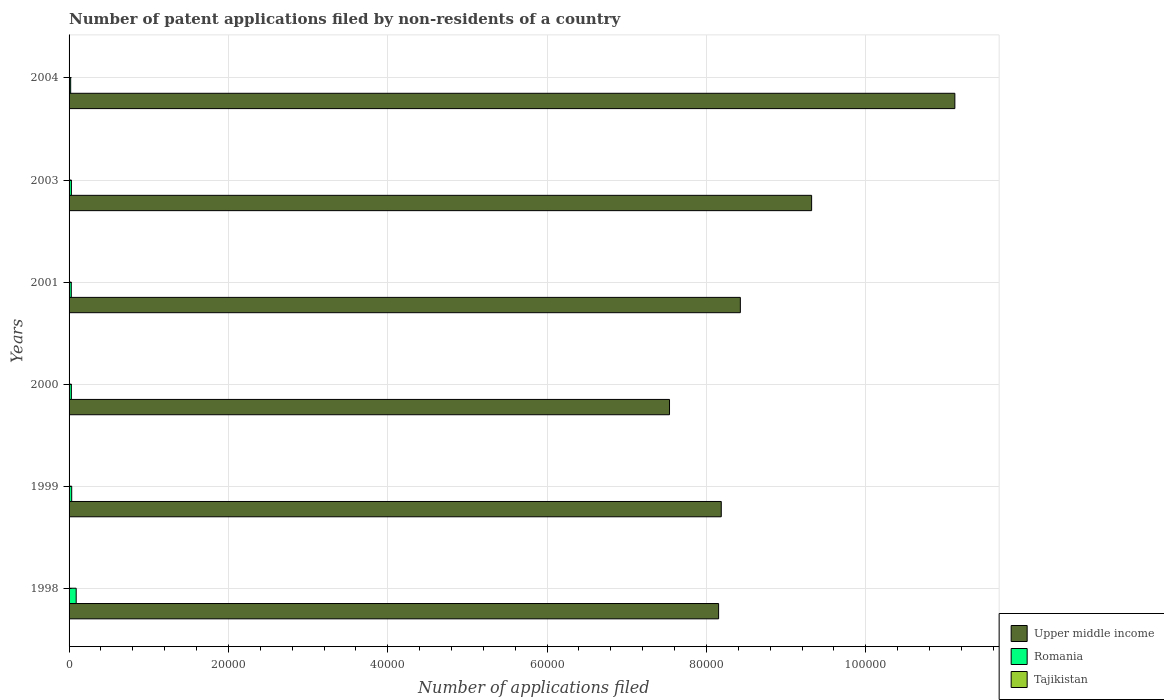How many different coloured bars are there?
Provide a succinct answer. 3. How many groups of bars are there?
Your answer should be very brief. 6. How many bars are there on the 3rd tick from the top?
Keep it short and to the point. 3. How many bars are there on the 2nd tick from the bottom?
Your answer should be compact. 3. What is the number of applications filed in Romania in 2004?
Ensure brevity in your answer.  200. Across all years, what is the minimum number of applications filed in Upper middle income?
Your response must be concise. 7.54e+04. In which year was the number of applications filed in Upper middle income maximum?
Your answer should be very brief. 2004. In which year was the number of applications filed in Upper middle income minimum?
Your answer should be compact. 2000. What is the total number of applications filed in Tajikistan in the graph?
Offer a very short reply. 25. What is the difference between the number of applications filed in Upper middle income in 1999 and the number of applications filed in Tajikistan in 2003?
Make the answer very short. 8.19e+04. What is the average number of applications filed in Romania per year?
Offer a terse response. 380.17. In the year 2003, what is the difference between the number of applications filed in Tajikistan and number of applications filed in Upper middle income?
Provide a short and direct response. -9.32e+04. In how many years, is the number of applications filed in Tajikistan greater than 44000 ?
Provide a short and direct response. 0. What is the ratio of the number of applications filed in Upper middle income in 2003 to that in 2004?
Keep it short and to the point. 0.84. Is the difference between the number of applications filed in Tajikistan in 1998 and 2003 greater than the difference between the number of applications filed in Upper middle income in 1998 and 2003?
Provide a short and direct response. Yes. What is the difference between the highest and the second highest number of applications filed in Tajikistan?
Give a very brief answer. 2. What is the difference between the highest and the lowest number of applications filed in Upper middle income?
Make the answer very short. 3.58e+04. In how many years, is the number of applications filed in Tajikistan greater than the average number of applications filed in Tajikistan taken over all years?
Ensure brevity in your answer.  3. Is the sum of the number of applications filed in Upper middle income in 1998 and 2001 greater than the maximum number of applications filed in Romania across all years?
Your response must be concise. Yes. What does the 1st bar from the top in 2004 represents?
Make the answer very short. Tajikistan. What does the 2nd bar from the bottom in 2004 represents?
Give a very brief answer. Romania. How many years are there in the graph?
Your answer should be very brief. 6. What is the difference between two consecutive major ticks on the X-axis?
Keep it short and to the point. 2.00e+04. What is the title of the graph?
Ensure brevity in your answer.  Number of patent applications filed by non-residents of a country. Does "Bolivia" appear as one of the legend labels in the graph?
Your answer should be compact. No. What is the label or title of the X-axis?
Your response must be concise. Number of applications filed. What is the Number of applications filed of Upper middle income in 1998?
Offer a very short reply. 8.15e+04. What is the Number of applications filed of Romania in 1998?
Your response must be concise. 894. What is the Number of applications filed of Tajikistan in 1998?
Ensure brevity in your answer.  9. What is the Number of applications filed in Upper middle income in 1999?
Offer a very short reply. 8.19e+04. What is the Number of applications filed of Romania in 1999?
Keep it short and to the point. 330. What is the Number of applications filed in Tajikistan in 1999?
Keep it short and to the point. 5. What is the Number of applications filed in Upper middle income in 2000?
Your response must be concise. 7.54e+04. What is the Number of applications filed of Romania in 2000?
Provide a succinct answer. 287. What is the Number of applications filed in Tajikistan in 2000?
Keep it short and to the point. 7. What is the Number of applications filed of Upper middle income in 2001?
Give a very brief answer. 8.43e+04. What is the Number of applications filed in Romania in 2001?
Offer a very short reply. 277. What is the Number of applications filed of Tajikistan in 2001?
Provide a succinct answer. 1. What is the Number of applications filed of Upper middle income in 2003?
Offer a very short reply. 9.32e+04. What is the Number of applications filed in Romania in 2003?
Keep it short and to the point. 293. What is the Number of applications filed of Tajikistan in 2003?
Your response must be concise. 1. What is the Number of applications filed of Upper middle income in 2004?
Give a very brief answer. 1.11e+05. What is the Number of applications filed in Tajikistan in 2004?
Keep it short and to the point. 2. Across all years, what is the maximum Number of applications filed in Upper middle income?
Your answer should be very brief. 1.11e+05. Across all years, what is the maximum Number of applications filed in Romania?
Your answer should be compact. 894. Across all years, what is the maximum Number of applications filed in Tajikistan?
Your response must be concise. 9. Across all years, what is the minimum Number of applications filed in Upper middle income?
Keep it short and to the point. 7.54e+04. Across all years, what is the minimum Number of applications filed in Romania?
Give a very brief answer. 200. Across all years, what is the minimum Number of applications filed in Tajikistan?
Offer a terse response. 1. What is the total Number of applications filed in Upper middle income in the graph?
Offer a very short reply. 5.27e+05. What is the total Number of applications filed of Romania in the graph?
Keep it short and to the point. 2281. What is the total Number of applications filed of Tajikistan in the graph?
Offer a very short reply. 25. What is the difference between the Number of applications filed of Upper middle income in 1998 and that in 1999?
Give a very brief answer. -333. What is the difference between the Number of applications filed of Romania in 1998 and that in 1999?
Provide a short and direct response. 564. What is the difference between the Number of applications filed in Upper middle income in 1998 and that in 2000?
Offer a terse response. 6162. What is the difference between the Number of applications filed in Romania in 1998 and that in 2000?
Your answer should be very brief. 607. What is the difference between the Number of applications filed of Upper middle income in 1998 and that in 2001?
Offer a terse response. -2727. What is the difference between the Number of applications filed of Romania in 1998 and that in 2001?
Provide a short and direct response. 617. What is the difference between the Number of applications filed in Upper middle income in 1998 and that in 2003?
Your answer should be very brief. -1.17e+04. What is the difference between the Number of applications filed of Romania in 1998 and that in 2003?
Ensure brevity in your answer.  601. What is the difference between the Number of applications filed in Upper middle income in 1998 and that in 2004?
Ensure brevity in your answer.  -2.97e+04. What is the difference between the Number of applications filed in Romania in 1998 and that in 2004?
Ensure brevity in your answer.  694. What is the difference between the Number of applications filed of Tajikistan in 1998 and that in 2004?
Your answer should be compact. 7. What is the difference between the Number of applications filed of Upper middle income in 1999 and that in 2000?
Offer a terse response. 6495. What is the difference between the Number of applications filed in Romania in 1999 and that in 2000?
Your answer should be very brief. 43. What is the difference between the Number of applications filed in Tajikistan in 1999 and that in 2000?
Offer a terse response. -2. What is the difference between the Number of applications filed of Upper middle income in 1999 and that in 2001?
Make the answer very short. -2394. What is the difference between the Number of applications filed of Tajikistan in 1999 and that in 2001?
Make the answer very short. 4. What is the difference between the Number of applications filed in Upper middle income in 1999 and that in 2003?
Provide a succinct answer. -1.13e+04. What is the difference between the Number of applications filed in Romania in 1999 and that in 2003?
Provide a short and direct response. 37. What is the difference between the Number of applications filed in Tajikistan in 1999 and that in 2003?
Ensure brevity in your answer.  4. What is the difference between the Number of applications filed of Upper middle income in 1999 and that in 2004?
Keep it short and to the point. -2.93e+04. What is the difference between the Number of applications filed in Romania in 1999 and that in 2004?
Keep it short and to the point. 130. What is the difference between the Number of applications filed in Tajikistan in 1999 and that in 2004?
Your answer should be compact. 3. What is the difference between the Number of applications filed of Upper middle income in 2000 and that in 2001?
Offer a very short reply. -8889. What is the difference between the Number of applications filed in Romania in 2000 and that in 2001?
Offer a terse response. 10. What is the difference between the Number of applications filed of Upper middle income in 2000 and that in 2003?
Ensure brevity in your answer.  -1.78e+04. What is the difference between the Number of applications filed of Tajikistan in 2000 and that in 2003?
Your response must be concise. 6. What is the difference between the Number of applications filed in Upper middle income in 2000 and that in 2004?
Offer a very short reply. -3.58e+04. What is the difference between the Number of applications filed of Romania in 2000 and that in 2004?
Keep it short and to the point. 87. What is the difference between the Number of applications filed of Tajikistan in 2000 and that in 2004?
Give a very brief answer. 5. What is the difference between the Number of applications filed in Upper middle income in 2001 and that in 2003?
Provide a short and direct response. -8949. What is the difference between the Number of applications filed in Tajikistan in 2001 and that in 2003?
Offer a very short reply. 0. What is the difference between the Number of applications filed of Upper middle income in 2001 and that in 2004?
Ensure brevity in your answer.  -2.69e+04. What is the difference between the Number of applications filed of Upper middle income in 2003 and that in 2004?
Your answer should be compact. -1.80e+04. What is the difference between the Number of applications filed of Romania in 2003 and that in 2004?
Your answer should be very brief. 93. What is the difference between the Number of applications filed of Tajikistan in 2003 and that in 2004?
Give a very brief answer. -1. What is the difference between the Number of applications filed in Upper middle income in 1998 and the Number of applications filed in Romania in 1999?
Your response must be concise. 8.12e+04. What is the difference between the Number of applications filed in Upper middle income in 1998 and the Number of applications filed in Tajikistan in 1999?
Your answer should be compact. 8.15e+04. What is the difference between the Number of applications filed in Romania in 1998 and the Number of applications filed in Tajikistan in 1999?
Your answer should be compact. 889. What is the difference between the Number of applications filed in Upper middle income in 1998 and the Number of applications filed in Romania in 2000?
Give a very brief answer. 8.12e+04. What is the difference between the Number of applications filed in Upper middle income in 1998 and the Number of applications filed in Tajikistan in 2000?
Your response must be concise. 8.15e+04. What is the difference between the Number of applications filed of Romania in 1998 and the Number of applications filed of Tajikistan in 2000?
Your answer should be compact. 887. What is the difference between the Number of applications filed in Upper middle income in 1998 and the Number of applications filed in Romania in 2001?
Keep it short and to the point. 8.13e+04. What is the difference between the Number of applications filed in Upper middle income in 1998 and the Number of applications filed in Tajikistan in 2001?
Make the answer very short. 8.15e+04. What is the difference between the Number of applications filed of Romania in 1998 and the Number of applications filed of Tajikistan in 2001?
Offer a terse response. 893. What is the difference between the Number of applications filed in Upper middle income in 1998 and the Number of applications filed in Romania in 2003?
Give a very brief answer. 8.12e+04. What is the difference between the Number of applications filed in Upper middle income in 1998 and the Number of applications filed in Tajikistan in 2003?
Provide a short and direct response. 8.15e+04. What is the difference between the Number of applications filed of Romania in 1998 and the Number of applications filed of Tajikistan in 2003?
Make the answer very short. 893. What is the difference between the Number of applications filed of Upper middle income in 1998 and the Number of applications filed of Romania in 2004?
Your answer should be compact. 8.13e+04. What is the difference between the Number of applications filed in Upper middle income in 1998 and the Number of applications filed in Tajikistan in 2004?
Ensure brevity in your answer.  8.15e+04. What is the difference between the Number of applications filed of Romania in 1998 and the Number of applications filed of Tajikistan in 2004?
Provide a succinct answer. 892. What is the difference between the Number of applications filed of Upper middle income in 1999 and the Number of applications filed of Romania in 2000?
Make the answer very short. 8.16e+04. What is the difference between the Number of applications filed in Upper middle income in 1999 and the Number of applications filed in Tajikistan in 2000?
Keep it short and to the point. 8.19e+04. What is the difference between the Number of applications filed in Romania in 1999 and the Number of applications filed in Tajikistan in 2000?
Your response must be concise. 323. What is the difference between the Number of applications filed of Upper middle income in 1999 and the Number of applications filed of Romania in 2001?
Provide a succinct answer. 8.16e+04. What is the difference between the Number of applications filed in Upper middle income in 1999 and the Number of applications filed in Tajikistan in 2001?
Offer a very short reply. 8.19e+04. What is the difference between the Number of applications filed of Romania in 1999 and the Number of applications filed of Tajikistan in 2001?
Your answer should be very brief. 329. What is the difference between the Number of applications filed in Upper middle income in 1999 and the Number of applications filed in Romania in 2003?
Ensure brevity in your answer.  8.16e+04. What is the difference between the Number of applications filed of Upper middle income in 1999 and the Number of applications filed of Tajikistan in 2003?
Your response must be concise. 8.19e+04. What is the difference between the Number of applications filed in Romania in 1999 and the Number of applications filed in Tajikistan in 2003?
Offer a very short reply. 329. What is the difference between the Number of applications filed in Upper middle income in 1999 and the Number of applications filed in Romania in 2004?
Keep it short and to the point. 8.17e+04. What is the difference between the Number of applications filed in Upper middle income in 1999 and the Number of applications filed in Tajikistan in 2004?
Provide a succinct answer. 8.19e+04. What is the difference between the Number of applications filed in Romania in 1999 and the Number of applications filed in Tajikistan in 2004?
Offer a very short reply. 328. What is the difference between the Number of applications filed of Upper middle income in 2000 and the Number of applications filed of Romania in 2001?
Keep it short and to the point. 7.51e+04. What is the difference between the Number of applications filed in Upper middle income in 2000 and the Number of applications filed in Tajikistan in 2001?
Provide a short and direct response. 7.54e+04. What is the difference between the Number of applications filed of Romania in 2000 and the Number of applications filed of Tajikistan in 2001?
Keep it short and to the point. 286. What is the difference between the Number of applications filed of Upper middle income in 2000 and the Number of applications filed of Romania in 2003?
Offer a very short reply. 7.51e+04. What is the difference between the Number of applications filed of Upper middle income in 2000 and the Number of applications filed of Tajikistan in 2003?
Ensure brevity in your answer.  7.54e+04. What is the difference between the Number of applications filed of Romania in 2000 and the Number of applications filed of Tajikistan in 2003?
Ensure brevity in your answer.  286. What is the difference between the Number of applications filed in Upper middle income in 2000 and the Number of applications filed in Romania in 2004?
Your response must be concise. 7.52e+04. What is the difference between the Number of applications filed in Upper middle income in 2000 and the Number of applications filed in Tajikistan in 2004?
Offer a terse response. 7.54e+04. What is the difference between the Number of applications filed in Romania in 2000 and the Number of applications filed in Tajikistan in 2004?
Your answer should be very brief. 285. What is the difference between the Number of applications filed of Upper middle income in 2001 and the Number of applications filed of Romania in 2003?
Your answer should be very brief. 8.40e+04. What is the difference between the Number of applications filed in Upper middle income in 2001 and the Number of applications filed in Tajikistan in 2003?
Provide a short and direct response. 8.43e+04. What is the difference between the Number of applications filed in Romania in 2001 and the Number of applications filed in Tajikistan in 2003?
Your answer should be compact. 276. What is the difference between the Number of applications filed of Upper middle income in 2001 and the Number of applications filed of Romania in 2004?
Give a very brief answer. 8.41e+04. What is the difference between the Number of applications filed in Upper middle income in 2001 and the Number of applications filed in Tajikistan in 2004?
Give a very brief answer. 8.43e+04. What is the difference between the Number of applications filed of Romania in 2001 and the Number of applications filed of Tajikistan in 2004?
Your answer should be compact. 275. What is the difference between the Number of applications filed in Upper middle income in 2003 and the Number of applications filed in Romania in 2004?
Your response must be concise. 9.30e+04. What is the difference between the Number of applications filed in Upper middle income in 2003 and the Number of applications filed in Tajikistan in 2004?
Give a very brief answer. 9.32e+04. What is the difference between the Number of applications filed in Romania in 2003 and the Number of applications filed in Tajikistan in 2004?
Give a very brief answer. 291. What is the average Number of applications filed of Upper middle income per year?
Ensure brevity in your answer.  8.79e+04. What is the average Number of applications filed of Romania per year?
Offer a very short reply. 380.17. What is the average Number of applications filed of Tajikistan per year?
Provide a succinct answer. 4.17. In the year 1998, what is the difference between the Number of applications filed of Upper middle income and Number of applications filed of Romania?
Provide a short and direct response. 8.06e+04. In the year 1998, what is the difference between the Number of applications filed in Upper middle income and Number of applications filed in Tajikistan?
Your answer should be very brief. 8.15e+04. In the year 1998, what is the difference between the Number of applications filed in Romania and Number of applications filed in Tajikistan?
Provide a short and direct response. 885. In the year 1999, what is the difference between the Number of applications filed of Upper middle income and Number of applications filed of Romania?
Keep it short and to the point. 8.15e+04. In the year 1999, what is the difference between the Number of applications filed in Upper middle income and Number of applications filed in Tajikistan?
Offer a terse response. 8.19e+04. In the year 1999, what is the difference between the Number of applications filed in Romania and Number of applications filed in Tajikistan?
Offer a very short reply. 325. In the year 2000, what is the difference between the Number of applications filed of Upper middle income and Number of applications filed of Romania?
Offer a very short reply. 7.51e+04. In the year 2000, what is the difference between the Number of applications filed in Upper middle income and Number of applications filed in Tajikistan?
Your answer should be very brief. 7.54e+04. In the year 2000, what is the difference between the Number of applications filed in Romania and Number of applications filed in Tajikistan?
Offer a terse response. 280. In the year 2001, what is the difference between the Number of applications filed of Upper middle income and Number of applications filed of Romania?
Your answer should be compact. 8.40e+04. In the year 2001, what is the difference between the Number of applications filed of Upper middle income and Number of applications filed of Tajikistan?
Your answer should be compact. 8.43e+04. In the year 2001, what is the difference between the Number of applications filed in Romania and Number of applications filed in Tajikistan?
Your response must be concise. 276. In the year 2003, what is the difference between the Number of applications filed in Upper middle income and Number of applications filed in Romania?
Your answer should be very brief. 9.29e+04. In the year 2003, what is the difference between the Number of applications filed of Upper middle income and Number of applications filed of Tajikistan?
Ensure brevity in your answer.  9.32e+04. In the year 2003, what is the difference between the Number of applications filed of Romania and Number of applications filed of Tajikistan?
Keep it short and to the point. 292. In the year 2004, what is the difference between the Number of applications filed of Upper middle income and Number of applications filed of Romania?
Your response must be concise. 1.11e+05. In the year 2004, what is the difference between the Number of applications filed in Upper middle income and Number of applications filed in Tajikistan?
Your answer should be compact. 1.11e+05. In the year 2004, what is the difference between the Number of applications filed of Romania and Number of applications filed of Tajikistan?
Make the answer very short. 198. What is the ratio of the Number of applications filed of Romania in 1998 to that in 1999?
Offer a very short reply. 2.71. What is the ratio of the Number of applications filed in Tajikistan in 1998 to that in 1999?
Provide a short and direct response. 1.8. What is the ratio of the Number of applications filed of Upper middle income in 1998 to that in 2000?
Provide a short and direct response. 1.08. What is the ratio of the Number of applications filed in Romania in 1998 to that in 2000?
Ensure brevity in your answer.  3.12. What is the ratio of the Number of applications filed of Upper middle income in 1998 to that in 2001?
Offer a very short reply. 0.97. What is the ratio of the Number of applications filed in Romania in 1998 to that in 2001?
Ensure brevity in your answer.  3.23. What is the ratio of the Number of applications filed of Upper middle income in 1998 to that in 2003?
Make the answer very short. 0.87. What is the ratio of the Number of applications filed in Romania in 1998 to that in 2003?
Give a very brief answer. 3.05. What is the ratio of the Number of applications filed in Upper middle income in 1998 to that in 2004?
Your answer should be very brief. 0.73. What is the ratio of the Number of applications filed of Romania in 1998 to that in 2004?
Provide a short and direct response. 4.47. What is the ratio of the Number of applications filed of Tajikistan in 1998 to that in 2004?
Your answer should be very brief. 4.5. What is the ratio of the Number of applications filed in Upper middle income in 1999 to that in 2000?
Your answer should be compact. 1.09. What is the ratio of the Number of applications filed in Romania in 1999 to that in 2000?
Your answer should be compact. 1.15. What is the ratio of the Number of applications filed in Upper middle income in 1999 to that in 2001?
Offer a very short reply. 0.97. What is the ratio of the Number of applications filed of Romania in 1999 to that in 2001?
Keep it short and to the point. 1.19. What is the ratio of the Number of applications filed in Upper middle income in 1999 to that in 2003?
Your answer should be compact. 0.88. What is the ratio of the Number of applications filed of Romania in 1999 to that in 2003?
Offer a terse response. 1.13. What is the ratio of the Number of applications filed in Tajikistan in 1999 to that in 2003?
Your answer should be very brief. 5. What is the ratio of the Number of applications filed in Upper middle income in 1999 to that in 2004?
Offer a terse response. 0.74. What is the ratio of the Number of applications filed in Romania in 1999 to that in 2004?
Offer a terse response. 1.65. What is the ratio of the Number of applications filed in Upper middle income in 2000 to that in 2001?
Make the answer very short. 0.89. What is the ratio of the Number of applications filed of Romania in 2000 to that in 2001?
Provide a short and direct response. 1.04. What is the ratio of the Number of applications filed in Tajikistan in 2000 to that in 2001?
Provide a short and direct response. 7. What is the ratio of the Number of applications filed of Upper middle income in 2000 to that in 2003?
Provide a short and direct response. 0.81. What is the ratio of the Number of applications filed in Romania in 2000 to that in 2003?
Your answer should be compact. 0.98. What is the ratio of the Number of applications filed of Tajikistan in 2000 to that in 2003?
Provide a succinct answer. 7. What is the ratio of the Number of applications filed in Upper middle income in 2000 to that in 2004?
Your answer should be compact. 0.68. What is the ratio of the Number of applications filed of Romania in 2000 to that in 2004?
Provide a short and direct response. 1.44. What is the ratio of the Number of applications filed in Tajikistan in 2000 to that in 2004?
Make the answer very short. 3.5. What is the ratio of the Number of applications filed of Upper middle income in 2001 to that in 2003?
Your response must be concise. 0.9. What is the ratio of the Number of applications filed in Romania in 2001 to that in 2003?
Offer a terse response. 0.95. What is the ratio of the Number of applications filed in Tajikistan in 2001 to that in 2003?
Give a very brief answer. 1. What is the ratio of the Number of applications filed in Upper middle income in 2001 to that in 2004?
Provide a short and direct response. 0.76. What is the ratio of the Number of applications filed in Romania in 2001 to that in 2004?
Keep it short and to the point. 1.39. What is the ratio of the Number of applications filed of Upper middle income in 2003 to that in 2004?
Make the answer very short. 0.84. What is the ratio of the Number of applications filed in Romania in 2003 to that in 2004?
Provide a short and direct response. 1.47. What is the ratio of the Number of applications filed in Tajikistan in 2003 to that in 2004?
Ensure brevity in your answer.  0.5. What is the difference between the highest and the second highest Number of applications filed of Upper middle income?
Provide a short and direct response. 1.80e+04. What is the difference between the highest and the second highest Number of applications filed in Romania?
Ensure brevity in your answer.  564. What is the difference between the highest and the second highest Number of applications filed of Tajikistan?
Make the answer very short. 2. What is the difference between the highest and the lowest Number of applications filed in Upper middle income?
Your answer should be very brief. 3.58e+04. What is the difference between the highest and the lowest Number of applications filed in Romania?
Ensure brevity in your answer.  694. What is the difference between the highest and the lowest Number of applications filed of Tajikistan?
Make the answer very short. 8. 